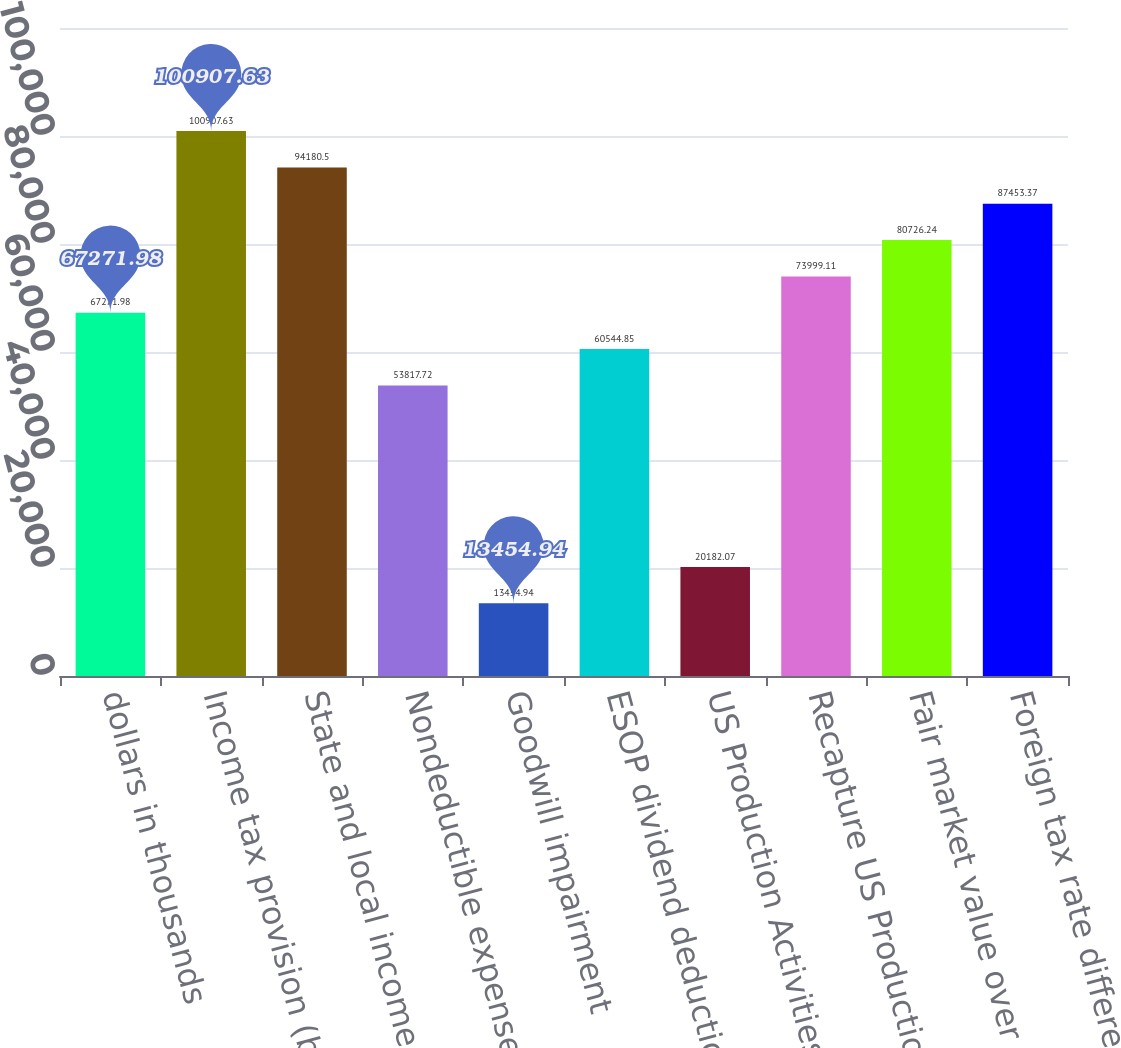<chart> <loc_0><loc_0><loc_500><loc_500><bar_chart><fcel>dollars in thousands<fcel>Income tax provision (benefit)<fcel>State and local income taxes<fcel>Nondeductible expense<fcel>Goodwill impairment<fcel>ESOP dividend deduction<fcel>US Production Activities<fcel>Recapture US Production<fcel>Fair market value over tax<fcel>Foreign tax rate differential<nl><fcel>67272<fcel>100908<fcel>94180.5<fcel>53817.7<fcel>13454.9<fcel>60544.8<fcel>20182.1<fcel>73999.1<fcel>80726.2<fcel>87453.4<nl></chart> 